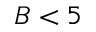Convert formula to latex. <formula><loc_0><loc_0><loc_500><loc_500>B < 5</formula> 